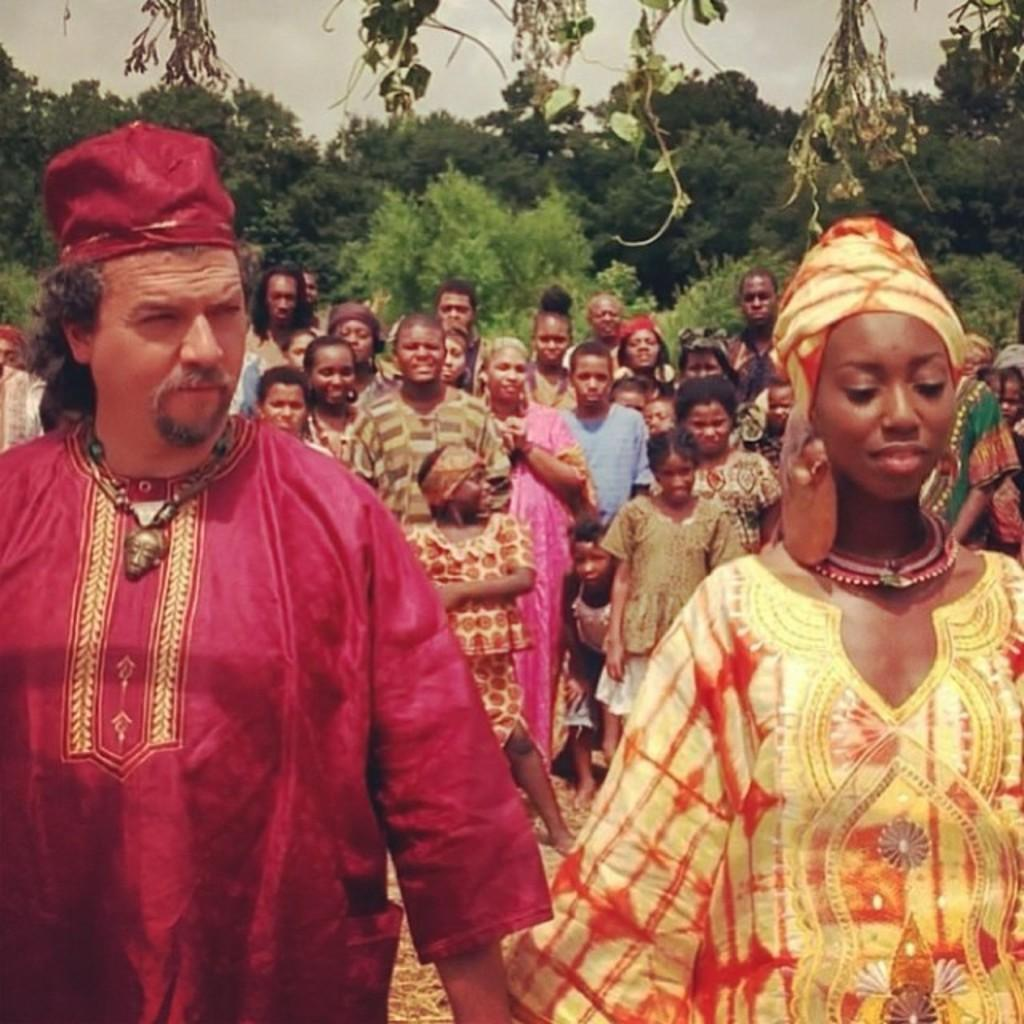How many people are present in the image? There are many people in the image. What other natural elements can be seen in the image besides people? There are many trees in the image. What is visible in the background of the image? The sky is visible in the image. Where is the vase located in the image? There is no vase present in the image. Can you see any cobwebs in the image? There are no cobwebs visible in the image. 